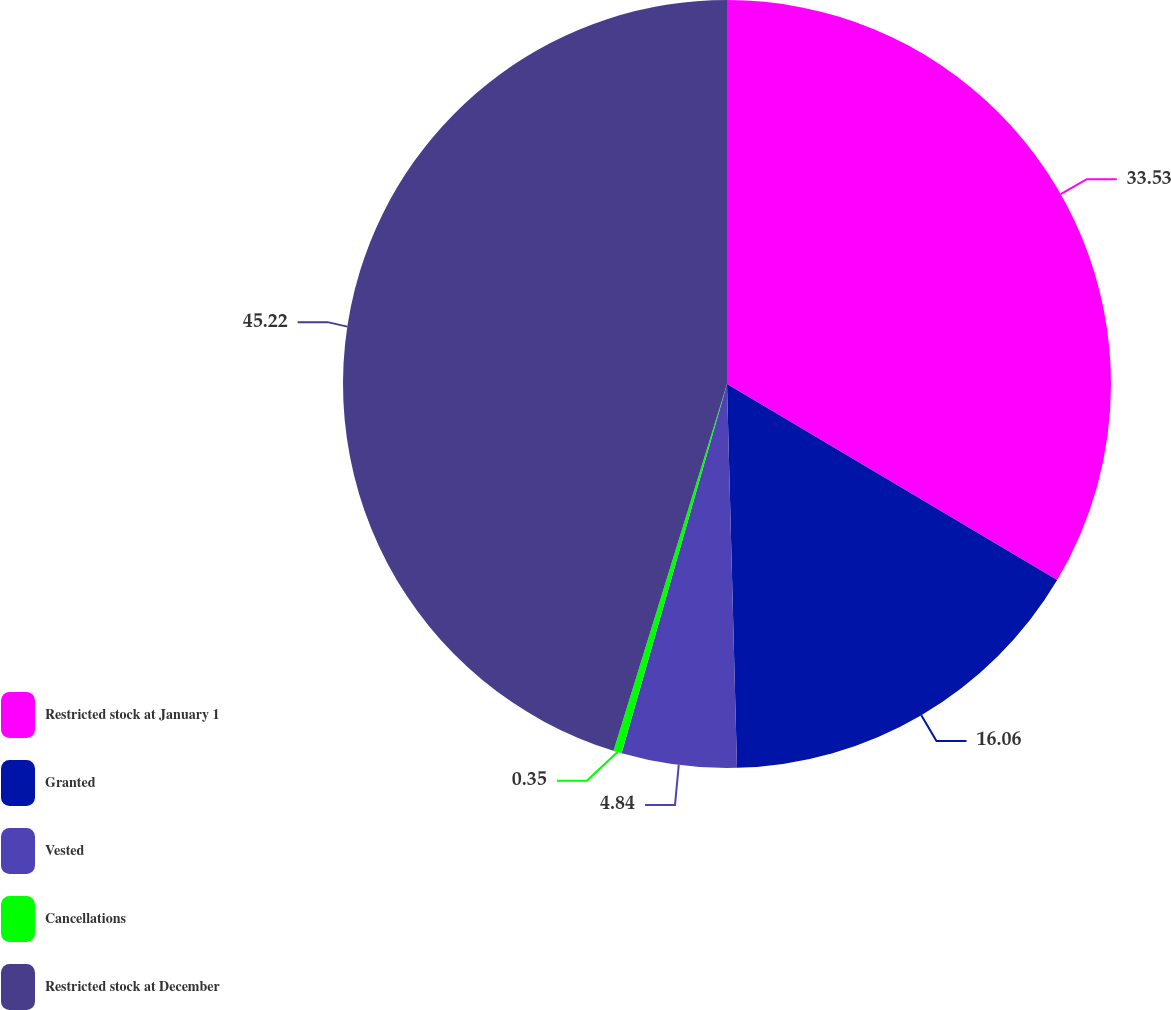Convert chart. <chart><loc_0><loc_0><loc_500><loc_500><pie_chart><fcel>Restricted stock at January 1<fcel>Granted<fcel>Vested<fcel>Cancellations<fcel>Restricted stock at December<nl><fcel>33.53%<fcel>16.06%<fcel>4.84%<fcel>0.35%<fcel>45.23%<nl></chart> 